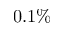<formula> <loc_0><loc_0><loc_500><loc_500>0 . 1 \%</formula> 